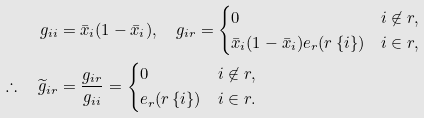<formula> <loc_0><loc_0><loc_500><loc_500>g _ { i i } & = \bar { x } _ { i } ( 1 - \bar { x } _ { i } ) , \quad g _ { i r } = \begin{cases} 0 & i \not \in r , \\ \bar { x } _ { i } ( 1 - \bar { x } _ { i } ) e _ { r } ( r \ \{ i \} ) & i \in r , \end{cases} \\ \therefore \quad \widetilde { g } _ { i r } & = \frac { g _ { i r } } { g _ { i i } } = \begin{cases} 0 & i \not \in r , \\ e _ { r } ( r \ \{ i \} ) & i \in r . \end{cases}</formula> 